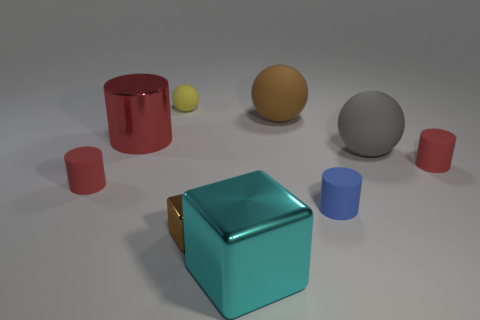Is there a gray ball of the same size as the brown metal object? no 